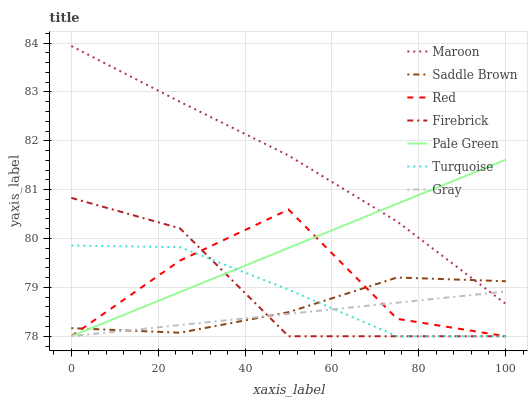Does Gray have the minimum area under the curve?
Answer yes or no. Yes. Does Maroon have the maximum area under the curve?
Answer yes or no. Yes. Does Turquoise have the minimum area under the curve?
Answer yes or no. No. Does Turquoise have the maximum area under the curve?
Answer yes or no. No. Is Pale Green the smoothest?
Answer yes or no. Yes. Is Red the roughest?
Answer yes or no. Yes. Is Turquoise the smoothest?
Answer yes or no. No. Is Turquoise the roughest?
Answer yes or no. No. Does Gray have the lowest value?
Answer yes or no. Yes. Does Maroon have the lowest value?
Answer yes or no. No. Does Maroon have the highest value?
Answer yes or no. Yes. Does Turquoise have the highest value?
Answer yes or no. No. Is Turquoise less than Maroon?
Answer yes or no. Yes. Is Maroon greater than Turquoise?
Answer yes or no. Yes. Does Gray intersect Turquoise?
Answer yes or no. Yes. Is Gray less than Turquoise?
Answer yes or no. No. Is Gray greater than Turquoise?
Answer yes or no. No. Does Turquoise intersect Maroon?
Answer yes or no. No. 